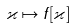Convert formula to latex. <formula><loc_0><loc_0><loc_500><loc_500>\varkappa \mapsto f [ \varkappa ]</formula> 